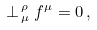<formula> <loc_0><loc_0><loc_500><loc_500>\perp ^ { \, \rho } _ { \, \mu } f ^ { \mu } = 0 \, ,</formula> 